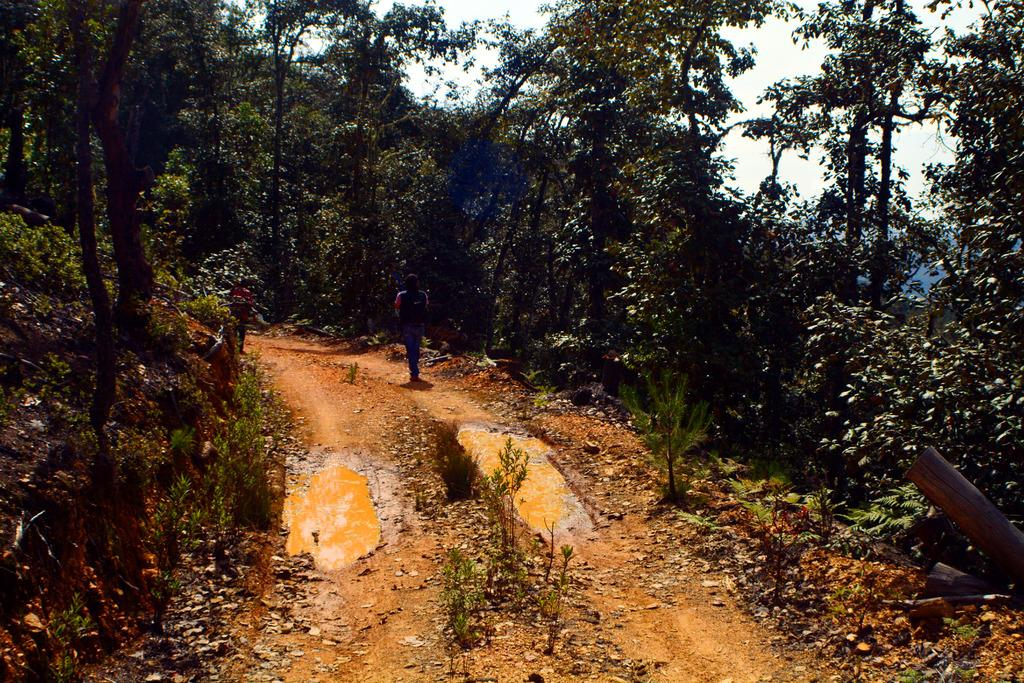What type of surface is visible in the image? There is ground in the image. What is on the ground in the image? There is water on the ground in the image. What other natural elements can be seen in the image? There are plants and trees in the image. Can you describe the person in the image? There is a person walking in the image. What is visible in the background of the image? There is a sky visible in the image. Where is the drain located in the image? There is no drain present in the image. What type of bath is the person taking in the image? There is no bath or any indication of a bathing activity in the image. 